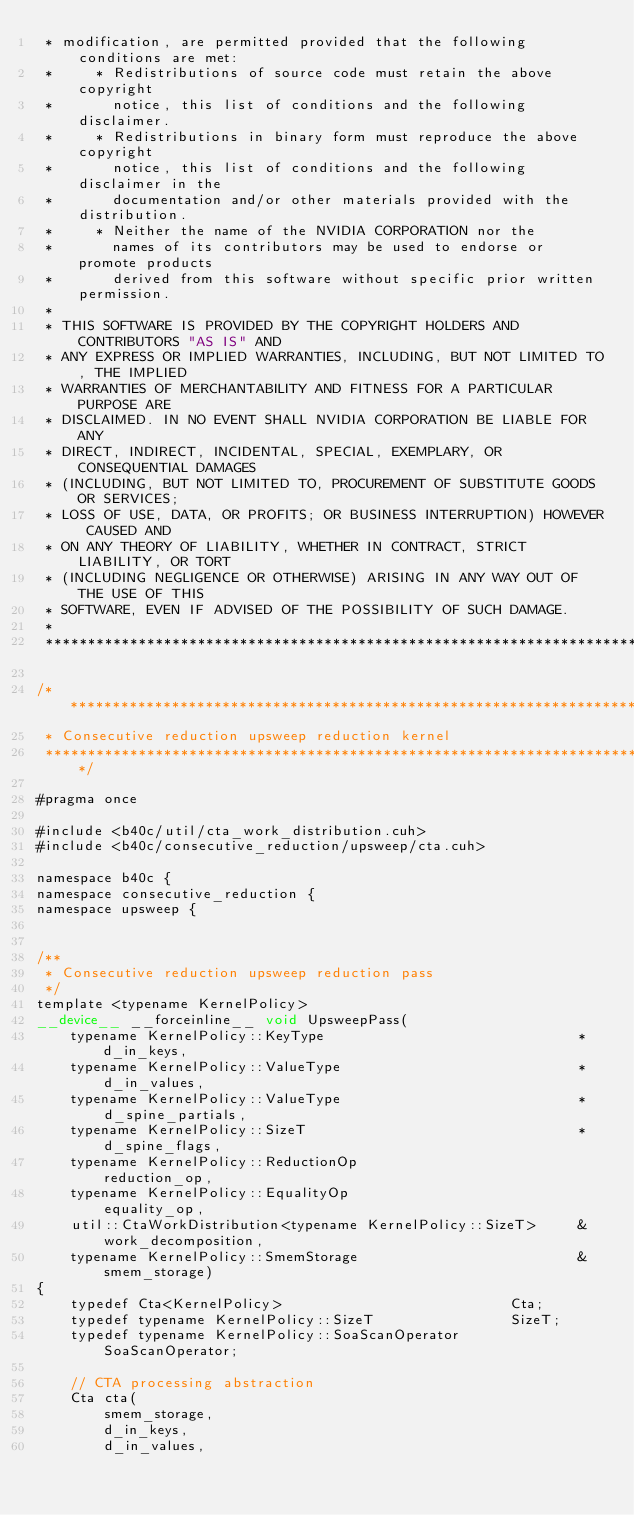Convert code to text. <code><loc_0><loc_0><loc_500><loc_500><_Cuda_> * modification, are permitted provided that the following conditions are met:
 *     * Redistributions of source code must retain the above copyright
 *       notice, this list of conditions and the following disclaimer.
 *     * Redistributions in binary form must reproduce the above copyright
 *       notice, this list of conditions and the following disclaimer in the
 *       documentation and/or other materials provided with the distribution.
 *     * Neither the name of the NVIDIA CORPORATION nor the
 *       names of its contributors may be used to endorse or promote products
 *       derived from this software without specific prior written permission.
 * 
 * THIS SOFTWARE IS PROVIDED BY THE COPYRIGHT HOLDERS AND CONTRIBUTORS "AS IS" AND
 * ANY EXPRESS OR IMPLIED WARRANTIES, INCLUDING, BUT NOT LIMITED TO, THE IMPLIED
 * WARRANTIES OF MERCHANTABILITY AND FITNESS FOR A PARTICULAR PURPOSE ARE
 * DISCLAIMED. IN NO EVENT SHALL NVIDIA CORPORATION BE LIABLE FOR ANY
 * DIRECT, INDIRECT, INCIDENTAL, SPECIAL, EXEMPLARY, OR CONSEQUENTIAL DAMAGES
 * (INCLUDING, BUT NOT LIMITED TO, PROCUREMENT OF SUBSTITUTE GOODS OR SERVICES;
 * LOSS OF USE, DATA, OR PROFITS; OR BUSINESS INTERRUPTION) HOWEVER CAUSED AND
 * ON ANY THEORY OF LIABILITY, WHETHER IN CONTRACT, STRICT LIABILITY, OR TORT
 * (INCLUDING NEGLIGENCE OR OTHERWISE) ARISING IN ANY WAY OUT OF THE USE OF THIS
 * SOFTWARE, EVEN IF ADVISED OF THE POSSIBILITY OF SUCH DAMAGE.
 *
 ******************************************************************************/

/******************************************************************************
 * Consecutive reduction upsweep reduction kernel
 ******************************************************************************/

#pragma once

#include <b40c/util/cta_work_distribution.cuh>
#include <b40c/consecutive_reduction/upsweep/cta.cuh>

namespace b40c {
namespace consecutive_reduction {
namespace upsweep {


/**
 * Consecutive reduction upsweep reduction pass
 */
template <typename KernelPolicy>
__device__ __forceinline__ void UpsweepPass(
	typename KernelPolicy::KeyType								*d_in_keys,
	typename KernelPolicy::ValueType							*d_in_values,
	typename KernelPolicy::ValueType 							*d_spine_partials,
	typename KernelPolicy::SizeT								*d_spine_flags,
	typename KernelPolicy::ReductionOp 							reduction_op,
	typename KernelPolicy::EqualityOp							equality_op,
	util::CtaWorkDistribution<typename KernelPolicy::SizeT> 	&work_decomposition,
	typename KernelPolicy::SmemStorage							&smem_storage)
{
	typedef Cta<KernelPolicy> 							Cta;
	typedef typename KernelPolicy::SizeT 				SizeT;
	typedef typename KernelPolicy::SoaScanOperator		SoaScanOperator;

	// CTA processing abstraction
	Cta cta(
		smem_storage,
		d_in_keys,
		d_in_values,</code> 